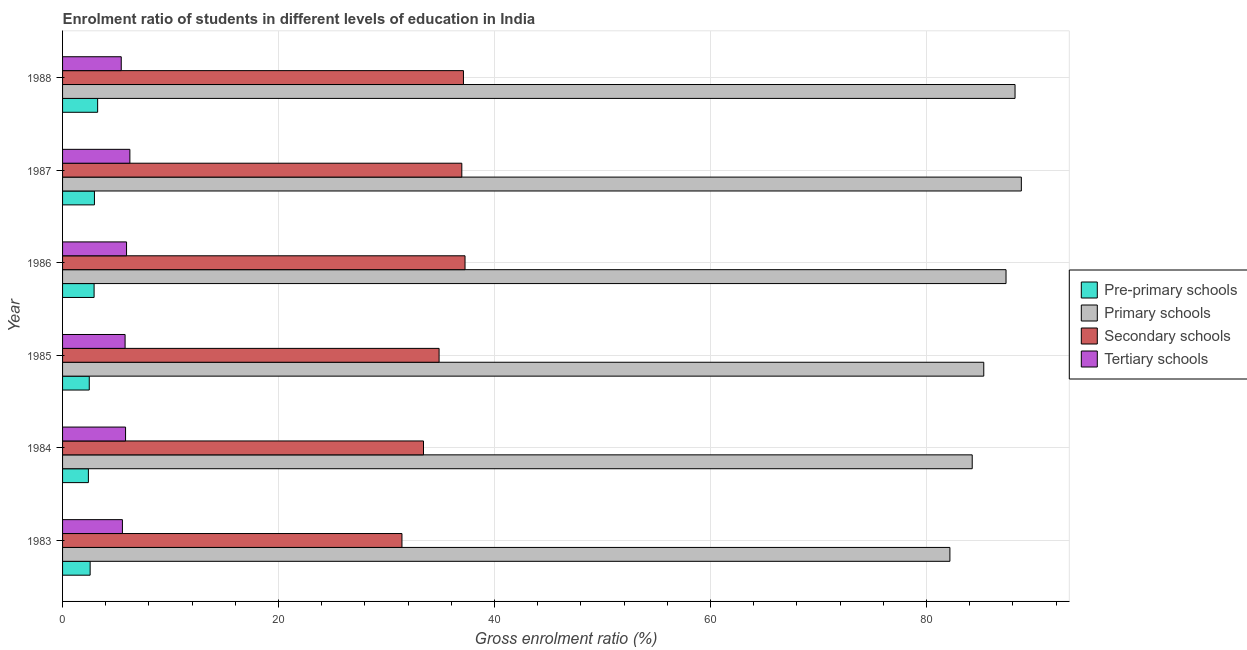How many groups of bars are there?
Keep it short and to the point. 6. Are the number of bars per tick equal to the number of legend labels?
Provide a succinct answer. Yes. What is the gross enrolment ratio in pre-primary schools in 1985?
Your response must be concise. 2.47. Across all years, what is the maximum gross enrolment ratio in tertiary schools?
Your answer should be very brief. 6.23. Across all years, what is the minimum gross enrolment ratio in pre-primary schools?
Ensure brevity in your answer.  2.39. In which year was the gross enrolment ratio in pre-primary schools maximum?
Your answer should be compact. 1988. What is the total gross enrolment ratio in tertiary schools in the graph?
Your answer should be very brief. 34.76. What is the difference between the gross enrolment ratio in primary schools in 1984 and that in 1987?
Your answer should be compact. -4.55. What is the difference between the gross enrolment ratio in pre-primary schools in 1988 and the gross enrolment ratio in secondary schools in 1983?
Offer a terse response. -28.18. What is the average gross enrolment ratio in primary schools per year?
Provide a short and direct response. 86.01. In the year 1987, what is the difference between the gross enrolment ratio in secondary schools and gross enrolment ratio in pre-primary schools?
Your answer should be very brief. 34.02. What is the ratio of the gross enrolment ratio in pre-primary schools in 1983 to that in 1988?
Keep it short and to the point. 0.79. Is the gross enrolment ratio in primary schools in 1984 less than that in 1988?
Make the answer very short. Yes. Is the difference between the gross enrolment ratio in pre-primary schools in 1984 and 1986 greater than the difference between the gross enrolment ratio in tertiary schools in 1984 and 1986?
Ensure brevity in your answer.  No. What is the difference between the highest and the second highest gross enrolment ratio in primary schools?
Your answer should be very brief. 0.58. What is the difference between the highest and the lowest gross enrolment ratio in tertiary schools?
Your answer should be compact. 0.8. Is the sum of the gross enrolment ratio in secondary schools in 1985 and 1988 greater than the maximum gross enrolment ratio in primary schools across all years?
Offer a terse response. No. What does the 2nd bar from the top in 1985 represents?
Your answer should be compact. Secondary schools. What does the 3rd bar from the bottom in 1984 represents?
Offer a terse response. Secondary schools. How many years are there in the graph?
Keep it short and to the point. 6. Are the values on the major ticks of X-axis written in scientific E-notation?
Provide a short and direct response. No. Does the graph contain any zero values?
Provide a succinct answer. No. How are the legend labels stacked?
Give a very brief answer. Vertical. What is the title of the graph?
Ensure brevity in your answer.  Enrolment ratio of students in different levels of education in India. Does "PFC gas" appear as one of the legend labels in the graph?
Make the answer very short. No. What is the label or title of the X-axis?
Offer a very short reply. Gross enrolment ratio (%). What is the Gross enrolment ratio (%) in Pre-primary schools in 1983?
Give a very brief answer. 2.55. What is the Gross enrolment ratio (%) of Primary schools in 1983?
Your response must be concise. 82.17. What is the Gross enrolment ratio (%) of Secondary schools in 1983?
Your answer should be very brief. 31.43. What is the Gross enrolment ratio (%) in Tertiary schools in 1983?
Your answer should be very brief. 5.54. What is the Gross enrolment ratio (%) of Pre-primary schools in 1984?
Ensure brevity in your answer.  2.39. What is the Gross enrolment ratio (%) of Primary schools in 1984?
Your response must be concise. 84.24. What is the Gross enrolment ratio (%) in Secondary schools in 1984?
Keep it short and to the point. 33.42. What is the Gross enrolment ratio (%) of Tertiary schools in 1984?
Offer a very short reply. 5.83. What is the Gross enrolment ratio (%) of Pre-primary schools in 1985?
Your answer should be compact. 2.47. What is the Gross enrolment ratio (%) of Primary schools in 1985?
Keep it short and to the point. 85.3. What is the Gross enrolment ratio (%) of Secondary schools in 1985?
Make the answer very short. 34.87. What is the Gross enrolment ratio (%) of Tertiary schools in 1985?
Keep it short and to the point. 5.79. What is the Gross enrolment ratio (%) in Pre-primary schools in 1986?
Your response must be concise. 2.92. What is the Gross enrolment ratio (%) of Primary schools in 1986?
Give a very brief answer. 87.37. What is the Gross enrolment ratio (%) in Secondary schools in 1986?
Your response must be concise. 37.27. What is the Gross enrolment ratio (%) in Tertiary schools in 1986?
Your answer should be very brief. 5.92. What is the Gross enrolment ratio (%) of Pre-primary schools in 1987?
Provide a short and direct response. 2.95. What is the Gross enrolment ratio (%) of Primary schools in 1987?
Keep it short and to the point. 88.79. What is the Gross enrolment ratio (%) in Secondary schools in 1987?
Provide a succinct answer. 36.97. What is the Gross enrolment ratio (%) in Tertiary schools in 1987?
Keep it short and to the point. 6.23. What is the Gross enrolment ratio (%) of Pre-primary schools in 1988?
Provide a succinct answer. 3.25. What is the Gross enrolment ratio (%) of Primary schools in 1988?
Your answer should be compact. 88.2. What is the Gross enrolment ratio (%) of Secondary schools in 1988?
Your response must be concise. 37.12. What is the Gross enrolment ratio (%) in Tertiary schools in 1988?
Offer a very short reply. 5.43. Across all years, what is the maximum Gross enrolment ratio (%) of Pre-primary schools?
Your response must be concise. 3.25. Across all years, what is the maximum Gross enrolment ratio (%) of Primary schools?
Your answer should be very brief. 88.79. Across all years, what is the maximum Gross enrolment ratio (%) of Secondary schools?
Your response must be concise. 37.27. Across all years, what is the maximum Gross enrolment ratio (%) in Tertiary schools?
Your answer should be very brief. 6.23. Across all years, what is the minimum Gross enrolment ratio (%) of Pre-primary schools?
Keep it short and to the point. 2.39. Across all years, what is the minimum Gross enrolment ratio (%) of Primary schools?
Your answer should be compact. 82.17. Across all years, what is the minimum Gross enrolment ratio (%) in Secondary schools?
Provide a succinct answer. 31.43. Across all years, what is the minimum Gross enrolment ratio (%) of Tertiary schools?
Ensure brevity in your answer.  5.43. What is the total Gross enrolment ratio (%) in Pre-primary schools in the graph?
Give a very brief answer. 16.54. What is the total Gross enrolment ratio (%) of Primary schools in the graph?
Provide a succinct answer. 516.06. What is the total Gross enrolment ratio (%) in Secondary schools in the graph?
Your answer should be compact. 211.08. What is the total Gross enrolment ratio (%) of Tertiary schools in the graph?
Give a very brief answer. 34.76. What is the difference between the Gross enrolment ratio (%) of Pre-primary schools in 1983 and that in 1984?
Provide a short and direct response. 0.16. What is the difference between the Gross enrolment ratio (%) in Primary schools in 1983 and that in 1984?
Provide a succinct answer. -2.07. What is the difference between the Gross enrolment ratio (%) of Secondary schools in 1983 and that in 1984?
Provide a short and direct response. -1.99. What is the difference between the Gross enrolment ratio (%) of Tertiary schools in 1983 and that in 1984?
Offer a terse response. -0.29. What is the difference between the Gross enrolment ratio (%) in Pre-primary schools in 1983 and that in 1985?
Your response must be concise. 0.08. What is the difference between the Gross enrolment ratio (%) of Primary schools in 1983 and that in 1985?
Provide a short and direct response. -3.13. What is the difference between the Gross enrolment ratio (%) in Secondary schools in 1983 and that in 1985?
Provide a succinct answer. -3.44. What is the difference between the Gross enrolment ratio (%) of Tertiary schools in 1983 and that in 1985?
Keep it short and to the point. -0.25. What is the difference between the Gross enrolment ratio (%) of Pre-primary schools in 1983 and that in 1986?
Make the answer very short. -0.37. What is the difference between the Gross enrolment ratio (%) in Primary schools in 1983 and that in 1986?
Your answer should be compact. -5.2. What is the difference between the Gross enrolment ratio (%) in Secondary schools in 1983 and that in 1986?
Your answer should be very brief. -5.84. What is the difference between the Gross enrolment ratio (%) of Tertiary schools in 1983 and that in 1986?
Give a very brief answer. -0.38. What is the difference between the Gross enrolment ratio (%) of Pre-primary schools in 1983 and that in 1987?
Provide a succinct answer. -0.4. What is the difference between the Gross enrolment ratio (%) in Primary schools in 1983 and that in 1987?
Offer a very short reply. -6.62. What is the difference between the Gross enrolment ratio (%) of Secondary schools in 1983 and that in 1987?
Offer a terse response. -5.54. What is the difference between the Gross enrolment ratio (%) of Tertiary schools in 1983 and that in 1987?
Keep it short and to the point. -0.69. What is the difference between the Gross enrolment ratio (%) in Pre-primary schools in 1983 and that in 1988?
Make the answer very short. -0.69. What is the difference between the Gross enrolment ratio (%) in Primary schools in 1983 and that in 1988?
Offer a terse response. -6.03. What is the difference between the Gross enrolment ratio (%) of Secondary schools in 1983 and that in 1988?
Your answer should be very brief. -5.69. What is the difference between the Gross enrolment ratio (%) in Tertiary schools in 1983 and that in 1988?
Provide a succinct answer. 0.11. What is the difference between the Gross enrolment ratio (%) of Pre-primary schools in 1984 and that in 1985?
Your response must be concise. -0.08. What is the difference between the Gross enrolment ratio (%) of Primary schools in 1984 and that in 1985?
Your answer should be compact. -1.07. What is the difference between the Gross enrolment ratio (%) in Secondary schools in 1984 and that in 1985?
Provide a succinct answer. -1.44. What is the difference between the Gross enrolment ratio (%) in Tertiary schools in 1984 and that in 1985?
Offer a very short reply. 0.04. What is the difference between the Gross enrolment ratio (%) of Pre-primary schools in 1984 and that in 1986?
Provide a succinct answer. -0.53. What is the difference between the Gross enrolment ratio (%) of Primary schools in 1984 and that in 1986?
Your answer should be very brief. -3.13. What is the difference between the Gross enrolment ratio (%) in Secondary schools in 1984 and that in 1986?
Your response must be concise. -3.85. What is the difference between the Gross enrolment ratio (%) of Tertiary schools in 1984 and that in 1986?
Your answer should be very brief. -0.09. What is the difference between the Gross enrolment ratio (%) in Pre-primary schools in 1984 and that in 1987?
Your answer should be compact. -0.56. What is the difference between the Gross enrolment ratio (%) of Primary schools in 1984 and that in 1987?
Keep it short and to the point. -4.55. What is the difference between the Gross enrolment ratio (%) of Secondary schools in 1984 and that in 1987?
Offer a very short reply. -3.55. What is the difference between the Gross enrolment ratio (%) in Tertiary schools in 1984 and that in 1987?
Make the answer very short. -0.4. What is the difference between the Gross enrolment ratio (%) in Pre-primary schools in 1984 and that in 1988?
Make the answer very short. -0.86. What is the difference between the Gross enrolment ratio (%) in Primary schools in 1984 and that in 1988?
Offer a terse response. -3.97. What is the difference between the Gross enrolment ratio (%) in Secondary schools in 1984 and that in 1988?
Your response must be concise. -3.7. What is the difference between the Gross enrolment ratio (%) in Tertiary schools in 1984 and that in 1988?
Provide a succinct answer. 0.4. What is the difference between the Gross enrolment ratio (%) of Pre-primary schools in 1985 and that in 1986?
Provide a short and direct response. -0.45. What is the difference between the Gross enrolment ratio (%) of Primary schools in 1985 and that in 1986?
Your answer should be very brief. -2.06. What is the difference between the Gross enrolment ratio (%) of Secondary schools in 1985 and that in 1986?
Provide a short and direct response. -2.4. What is the difference between the Gross enrolment ratio (%) in Tertiary schools in 1985 and that in 1986?
Offer a terse response. -0.13. What is the difference between the Gross enrolment ratio (%) in Pre-primary schools in 1985 and that in 1987?
Offer a very short reply. -0.48. What is the difference between the Gross enrolment ratio (%) in Primary schools in 1985 and that in 1987?
Keep it short and to the point. -3.48. What is the difference between the Gross enrolment ratio (%) in Secondary schools in 1985 and that in 1987?
Offer a very short reply. -2.1. What is the difference between the Gross enrolment ratio (%) in Tertiary schools in 1985 and that in 1987?
Your answer should be very brief. -0.44. What is the difference between the Gross enrolment ratio (%) of Pre-primary schools in 1985 and that in 1988?
Make the answer very short. -0.78. What is the difference between the Gross enrolment ratio (%) of Primary schools in 1985 and that in 1988?
Offer a very short reply. -2.9. What is the difference between the Gross enrolment ratio (%) in Secondary schools in 1985 and that in 1988?
Provide a succinct answer. -2.26. What is the difference between the Gross enrolment ratio (%) of Tertiary schools in 1985 and that in 1988?
Offer a terse response. 0.36. What is the difference between the Gross enrolment ratio (%) of Pre-primary schools in 1986 and that in 1987?
Your response must be concise. -0.03. What is the difference between the Gross enrolment ratio (%) of Primary schools in 1986 and that in 1987?
Your answer should be very brief. -1.42. What is the difference between the Gross enrolment ratio (%) in Secondary schools in 1986 and that in 1987?
Provide a short and direct response. 0.3. What is the difference between the Gross enrolment ratio (%) of Tertiary schools in 1986 and that in 1987?
Keep it short and to the point. -0.31. What is the difference between the Gross enrolment ratio (%) of Pre-primary schools in 1986 and that in 1988?
Keep it short and to the point. -0.33. What is the difference between the Gross enrolment ratio (%) of Primary schools in 1986 and that in 1988?
Keep it short and to the point. -0.84. What is the difference between the Gross enrolment ratio (%) of Secondary schools in 1986 and that in 1988?
Your response must be concise. 0.15. What is the difference between the Gross enrolment ratio (%) of Tertiary schools in 1986 and that in 1988?
Your response must be concise. 0.49. What is the difference between the Gross enrolment ratio (%) of Pre-primary schools in 1987 and that in 1988?
Your answer should be very brief. -0.3. What is the difference between the Gross enrolment ratio (%) in Primary schools in 1987 and that in 1988?
Your answer should be compact. 0.58. What is the difference between the Gross enrolment ratio (%) in Secondary schools in 1987 and that in 1988?
Make the answer very short. -0.15. What is the difference between the Gross enrolment ratio (%) of Tertiary schools in 1987 and that in 1988?
Offer a very short reply. 0.8. What is the difference between the Gross enrolment ratio (%) of Pre-primary schools in 1983 and the Gross enrolment ratio (%) of Primary schools in 1984?
Offer a very short reply. -81.68. What is the difference between the Gross enrolment ratio (%) in Pre-primary schools in 1983 and the Gross enrolment ratio (%) in Secondary schools in 1984?
Provide a succinct answer. -30.87. What is the difference between the Gross enrolment ratio (%) of Pre-primary schools in 1983 and the Gross enrolment ratio (%) of Tertiary schools in 1984?
Ensure brevity in your answer.  -3.28. What is the difference between the Gross enrolment ratio (%) of Primary schools in 1983 and the Gross enrolment ratio (%) of Secondary schools in 1984?
Provide a short and direct response. 48.75. What is the difference between the Gross enrolment ratio (%) of Primary schools in 1983 and the Gross enrolment ratio (%) of Tertiary schools in 1984?
Provide a short and direct response. 76.34. What is the difference between the Gross enrolment ratio (%) in Secondary schools in 1983 and the Gross enrolment ratio (%) in Tertiary schools in 1984?
Keep it short and to the point. 25.59. What is the difference between the Gross enrolment ratio (%) in Pre-primary schools in 1983 and the Gross enrolment ratio (%) in Primary schools in 1985?
Keep it short and to the point. -82.75. What is the difference between the Gross enrolment ratio (%) of Pre-primary schools in 1983 and the Gross enrolment ratio (%) of Secondary schools in 1985?
Your answer should be compact. -32.31. What is the difference between the Gross enrolment ratio (%) of Pre-primary schools in 1983 and the Gross enrolment ratio (%) of Tertiary schools in 1985?
Your answer should be compact. -3.24. What is the difference between the Gross enrolment ratio (%) in Primary schools in 1983 and the Gross enrolment ratio (%) in Secondary schools in 1985?
Provide a succinct answer. 47.3. What is the difference between the Gross enrolment ratio (%) in Primary schools in 1983 and the Gross enrolment ratio (%) in Tertiary schools in 1985?
Offer a very short reply. 76.38. What is the difference between the Gross enrolment ratio (%) of Secondary schools in 1983 and the Gross enrolment ratio (%) of Tertiary schools in 1985?
Give a very brief answer. 25.64. What is the difference between the Gross enrolment ratio (%) of Pre-primary schools in 1983 and the Gross enrolment ratio (%) of Primary schools in 1986?
Your answer should be very brief. -84.81. What is the difference between the Gross enrolment ratio (%) of Pre-primary schools in 1983 and the Gross enrolment ratio (%) of Secondary schools in 1986?
Ensure brevity in your answer.  -34.72. What is the difference between the Gross enrolment ratio (%) of Pre-primary schools in 1983 and the Gross enrolment ratio (%) of Tertiary schools in 1986?
Your answer should be compact. -3.37. What is the difference between the Gross enrolment ratio (%) in Primary schools in 1983 and the Gross enrolment ratio (%) in Secondary schools in 1986?
Give a very brief answer. 44.9. What is the difference between the Gross enrolment ratio (%) in Primary schools in 1983 and the Gross enrolment ratio (%) in Tertiary schools in 1986?
Make the answer very short. 76.25. What is the difference between the Gross enrolment ratio (%) of Secondary schools in 1983 and the Gross enrolment ratio (%) of Tertiary schools in 1986?
Your response must be concise. 25.5. What is the difference between the Gross enrolment ratio (%) in Pre-primary schools in 1983 and the Gross enrolment ratio (%) in Primary schools in 1987?
Your answer should be compact. -86.23. What is the difference between the Gross enrolment ratio (%) in Pre-primary schools in 1983 and the Gross enrolment ratio (%) in Secondary schools in 1987?
Provide a succinct answer. -34.42. What is the difference between the Gross enrolment ratio (%) of Pre-primary schools in 1983 and the Gross enrolment ratio (%) of Tertiary schools in 1987?
Your answer should be compact. -3.68. What is the difference between the Gross enrolment ratio (%) of Primary schools in 1983 and the Gross enrolment ratio (%) of Secondary schools in 1987?
Offer a terse response. 45.2. What is the difference between the Gross enrolment ratio (%) of Primary schools in 1983 and the Gross enrolment ratio (%) of Tertiary schools in 1987?
Your answer should be very brief. 75.94. What is the difference between the Gross enrolment ratio (%) of Secondary schools in 1983 and the Gross enrolment ratio (%) of Tertiary schools in 1987?
Keep it short and to the point. 25.2. What is the difference between the Gross enrolment ratio (%) of Pre-primary schools in 1983 and the Gross enrolment ratio (%) of Primary schools in 1988?
Offer a terse response. -85.65. What is the difference between the Gross enrolment ratio (%) of Pre-primary schools in 1983 and the Gross enrolment ratio (%) of Secondary schools in 1988?
Your response must be concise. -34.57. What is the difference between the Gross enrolment ratio (%) of Pre-primary schools in 1983 and the Gross enrolment ratio (%) of Tertiary schools in 1988?
Offer a terse response. -2.88. What is the difference between the Gross enrolment ratio (%) in Primary schools in 1983 and the Gross enrolment ratio (%) in Secondary schools in 1988?
Make the answer very short. 45.05. What is the difference between the Gross enrolment ratio (%) of Primary schools in 1983 and the Gross enrolment ratio (%) of Tertiary schools in 1988?
Make the answer very short. 76.74. What is the difference between the Gross enrolment ratio (%) of Secondary schools in 1983 and the Gross enrolment ratio (%) of Tertiary schools in 1988?
Your answer should be very brief. 25.99. What is the difference between the Gross enrolment ratio (%) of Pre-primary schools in 1984 and the Gross enrolment ratio (%) of Primary schools in 1985?
Provide a succinct answer. -82.91. What is the difference between the Gross enrolment ratio (%) of Pre-primary schools in 1984 and the Gross enrolment ratio (%) of Secondary schools in 1985?
Give a very brief answer. -32.47. What is the difference between the Gross enrolment ratio (%) in Pre-primary schools in 1984 and the Gross enrolment ratio (%) in Tertiary schools in 1985?
Your response must be concise. -3.4. What is the difference between the Gross enrolment ratio (%) in Primary schools in 1984 and the Gross enrolment ratio (%) in Secondary schools in 1985?
Your answer should be compact. 49.37. What is the difference between the Gross enrolment ratio (%) in Primary schools in 1984 and the Gross enrolment ratio (%) in Tertiary schools in 1985?
Your answer should be compact. 78.45. What is the difference between the Gross enrolment ratio (%) of Secondary schools in 1984 and the Gross enrolment ratio (%) of Tertiary schools in 1985?
Your answer should be very brief. 27.63. What is the difference between the Gross enrolment ratio (%) in Pre-primary schools in 1984 and the Gross enrolment ratio (%) in Primary schools in 1986?
Make the answer very short. -84.98. What is the difference between the Gross enrolment ratio (%) in Pre-primary schools in 1984 and the Gross enrolment ratio (%) in Secondary schools in 1986?
Make the answer very short. -34.88. What is the difference between the Gross enrolment ratio (%) in Pre-primary schools in 1984 and the Gross enrolment ratio (%) in Tertiary schools in 1986?
Your answer should be very brief. -3.53. What is the difference between the Gross enrolment ratio (%) in Primary schools in 1984 and the Gross enrolment ratio (%) in Secondary schools in 1986?
Your answer should be compact. 46.97. What is the difference between the Gross enrolment ratio (%) of Primary schools in 1984 and the Gross enrolment ratio (%) of Tertiary schools in 1986?
Keep it short and to the point. 78.31. What is the difference between the Gross enrolment ratio (%) in Secondary schools in 1984 and the Gross enrolment ratio (%) in Tertiary schools in 1986?
Offer a very short reply. 27.5. What is the difference between the Gross enrolment ratio (%) of Pre-primary schools in 1984 and the Gross enrolment ratio (%) of Primary schools in 1987?
Offer a very short reply. -86.39. What is the difference between the Gross enrolment ratio (%) in Pre-primary schools in 1984 and the Gross enrolment ratio (%) in Secondary schools in 1987?
Provide a succinct answer. -34.58. What is the difference between the Gross enrolment ratio (%) in Pre-primary schools in 1984 and the Gross enrolment ratio (%) in Tertiary schools in 1987?
Give a very brief answer. -3.84. What is the difference between the Gross enrolment ratio (%) in Primary schools in 1984 and the Gross enrolment ratio (%) in Secondary schools in 1987?
Ensure brevity in your answer.  47.26. What is the difference between the Gross enrolment ratio (%) of Primary schools in 1984 and the Gross enrolment ratio (%) of Tertiary schools in 1987?
Your answer should be compact. 78. What is the difference between the Gross enrolment ratio (%) of Secondary schools in 1984 and the Gross enrolment ratio (%) of Tertiary schools in 1987?
Make the answer very short. 27.19. What is the difference between the Gross enrolment ratio (%) in Pre-primary schools in 1984 and the Gross enrolment ratio (%) in Primary schools in 1988?
Your answer should be very brief. -85.81. What is the difference between the Gross enrolment ratio (%) of Pre-primary schools in 1984 and the Gross enrolment ratio (%) of Secondary schools in 1988?
Keep it short and to the point. -34.73. What is the difference between the Gross enrolment ratio (%) in Pre-primary schools in 1984 and the Gross enrolment ratio (%) in Tertiary schools in 1988?
Make the answer very short. -3.04. What is the difference between the Gross enrolment ratio (%) of Primary schools in 1984 and the Gross enrolment ratio (%) of Secondary schools in 1988?
Ensure brevity in your answer.  47.11. What is the difference between the Gross enrolment ratio (%) of Primary schools in 1984 and the Gross enrolment ratio (%) of Tertiary schools in 1988?
Your answer should be very brief. 78.8. What is the difference between the Gross enrolment ratio (%) of Secondary schools in 1984 and the Gross enrolment ratio (%) of Tertiary schools in 1988?
Provide a short and direct response. 27.99. What is the difference between the Gross enrolment ratio (%) of Pre-primary schools in 1985 and the Gross enrolment ratio (%) of Primary schools in 1986?
Offer a terse response. -84.89. What is the difference between the Gross enrolment ratio (%) in Pre-primary schools in 1985 and the Gross enrolment ratio (%) in Secondary schools in 1986?
Offer a terse response. -34.8. What is the difference between the Gross enrolment ratio (%) in Pre-primary schools in 1985 and the Gross enrolment ratio (%) in Tertiary schools in 1986?
Your answer should be compact. -3.45. What is the difference between the Gross enrolment ratio (%) of Primary schools in 1985 and the Gross enrolment ratio (%) of Secondary schools in 1986?
Provide a succinct answer. 48.03. What is the difference between the Gross enrolment ratio (%) of Primary schools in 1985 and the Gross enrolment ratio (%) of Tertiary schools in 1986?
Offer a terse response. 79.38. What is the difference between the Gross enrolment ratio (%) of Secondary schools in 1985 and the Gross enrolment ratio (%) of Tertiary schools in 1986?
Your response must be concise. 28.94. What is the difference between the Gross enrolment ratio (%) in Pre-primary schools in 1985 and the Gross enrolment ratio (%) in Primary schools in 1987?
Offer a very short reply. -86.31. What is the difference between the Gross enrolment ratio (%) in Pre-primary schools in 1985 and the Gross enrolment ratio (%) in Secondary schools in 1987?
Your answer should be very brief. -34.5. What is the difference between the Gross enrolment ratio (%) in Pre-primary schools in 1985 and the Gross enrolment ratio (%) in Tertiary schools in 1987?
Make the answer very short. -3.76. What is the difference between the Gross enrolment ratio (%) in Primary schools in 1985 and the Gross enrolment ratio (%) in Secondary schools in 1987?
Offer a very short reply. 48.33. What is the difference between the Gross enrolment ratio (%) of Primary schools in 1985 and the Gross enrolment ratio (%) of Tertiary schools in 1987?
Your answer should be compact. 79.07. What is the difference between the Gross enrolment ratio (%) of Secondary schools in 1985 and the Gross enrolment ratio (%) of Tertiary schools in 1987?
Your answer should be very brief. 28.63. What is the difference between the Gross enrolment ratio (%) in Pre-primary schools in 1985 and the Gross enrolment ratio (%) in Primary schools in 1988?
Your answer should be compact. -85.73. What is the difference between the Gross enrolment ratio (%) of Pre-primary schools in 1985 and the Gross enrolment ratio (%) of Secondary schools in 1988?
Provide a succinct answer. -34.65. What is the difference between the Gross enrolment ratio (%) in Pre-primary schools in 1985 and the Gross enrolment ratio (%) in Tertiary schools in 1988?
Give a very brief answer. -2.96. What is the difference between the Gross enrolment ratio (%) of Primary schools in 1985 and the Gross enrolment ratio (%) of Secondary schools in 1988?
Provide a short and direct response. 48.18. What is the difference between the Gross enrolment ratio (%) in Primary schools in 1985 and the Gross enrolment ratio (%) in Tertiary schools in 1988?
Your response must be concise. 79.87. What is the difference between the Gross enrolment ratio (%) of Secondary schools in 1985 and the Gross enrolment ratio (%) of Tertiary schools in 1988?
Your answer should be very brief. 29.43. What is the difference between the Gross enrolment ratio (%) of Pre-primary schools in 1986 and the Gross enrolment ratio (%) of Primary schools in 1987?
Make the answer very short. -85.87. What is the difference between the Gross enrolment ratio (%) of Pre-primary schools in 1986 and the Gross enrolment ratio (%) of Secondary schools in 1987?
Offer a very short reply. -34.05. What is the difference between the Gross enrolment ratio (%) in Pre-primary schools in 1986 and the Gross enrolment ratio (%) in Tertiary schools in 1987?
Offer a terse response. -3.31. What is the difference between the Gross enrolment ratio (%) in Primary schools in 1986 and the Gross enrolment ratio (%) in Secondary schools in 1987?
Your answer should be compact. 50.4. What is the difference between the Gross enrolment ratio (%) in Primary schools in 1986 and the Gross enrolment ratio (%) in Tertiary schools in 1987?
Make the answer very short. 81.13. What is the difference between the Gross enrolment ratio (%) of Secondary schools in 1986 and the Gross enrolment ratio (%) of Tertiary schools in 1987?
Offer a very short reply. 31.04. What is the difference between the Gross enrolment ratio (%) of Pre-primary schools in 1986 and the Gross enrolment ratio (%) of Primary schools in 1988?
Make the answer very short. -85.28. What is the difference between the Gross enrolment ratio (%) in Pre-primary schools in 1986 and the Gross enrolment ratio (%) in Secondary schools in 1988?
Your answer should be compact. -34.2. What is the difference between the Gross enrolment ratio (%) in Pre-primary schools in 1986 and the Gross enrolment ratio (%) in Tertiary schools in 1988?
Provide a succinct answer. -2.51. What is the difference between the Gross enrolment ratio (%) of Primary schools in 1986 and the Gross enrolment ratio (%) of Secondary schools in 1988?
Your answer should be compact. 50.24. What is the difference between the Gross enrolment ratio (%) of Primary schools in 1986 and the Gross enrolment ratio (%) of Tertiary schools in 1988?
Your answer should be compact. 81.93. What is the difference between the Gross enrolment ratio (%) of Secondary schools in 1986 and the Gross enrolment ratio (%) of Tertiary schools in 1988?
Provide a short and direct response. 31.84. What is the difference between the Gross enrolment ratio (%) in Pre-primary schools in 1987 and the Gross enrolment ratio (%) in Primary schools in 1988?
Keep it short and to the point. -85.25. What is the difference between the Gross enrolment ratio (%) in Pre-primary schools in 1987 and the Gross enrolment ratio (%) in Secondary schools in 1988?
Make the answer very short. -34.17. What is the difference between the Gross enrolment ratio (%) of Pre-primary schools in 1987 and the Gross enrolment ratio (%) of Tertiary schools in 1988?
Offer a very short reply. -2.48. What is the difference between the Gross enrolment ratio (%) in Primary schools in 1987 and the Gross enrolment ratio (%) in Secondary schools in 1988?
Give a very brief answer. 51.66. What is the difference between the Gross enrolment ratio (%) in Primary schools in 1987 and the Gross enrolment ratio (%) in Tertiary schools in 1988?
Your answer should be compact. 83.35. What is the difference between the Gross enrolment ratio (%) in Secondary schools in 1987 and the Gross enrolment ratio (%) in Tertiary schools in 1988?
Your answer should be compact. 31.54. What is the average Gross enrolment ratio (%) of Pre-primary schools per year?
Keep it short and to the point. 2.76. What is the average Gross enrolment ratio (%) in Primary schools per year?
Make the answer very short. 86.01. What is the average Gross enrolment ratio (%) of Secondary schools per year?
Offer a terse response. 35.18. What is the average Gross enrolment ratio (%) in Tertiary schools per year?
Ensure brevity in your answer.  5.79. In the year 1983, what is the difference between the Gross enrolment ratio (%) in Pre-primary schools and Gross enrolment ratio (%) in Primary schools?
Your answer should be compact. -79.62. In the year 1983, what is the difference between the Gross enrolment ratio (%) in Pre-primary schools and Gross enrolment ratio (%) in Secondary schools?
Your answer should be very brief. -28.87. In the year 1983, what is the difference between the Gross enrolment ratio (%) in Pre-primary schools and Gross enrolment ratio (%) in Tertiary schools?
Give a very brief answer. -2.99. In the year 1983, what is the difference between the Gross enrolment ratio (%) in Primary schools and Gross enrolment ratio (%) in Secondary schools?
Ensure brevity in your answer.  50.74. In the year 1983, what is the difference between the Gross enrolment ratio (%) of Primary schools and Gross enrolment ratio (%) of Tertiary schools?
Ensure brevity in your answer.  76.63. In the year 1983, what is the difference between the Gross enrolment ratio (%) in Secondary schools and Gross enrolment ratio (%) in Tertiary schools?
Offer a terse response. 25.89. In the year 1984, what is the difference between the Gross enrolment ratio (%) of Pre-primary schools and Gross enrolment ratio (%) of Primary schools?
Give a very brief answer. -81.84. In the year 1984, what is the difference between the Gross enrolment ratio (%) in Pre-primary schools and Gross enrolment ratio (%) in Secondary schools?
Keep it short and to the point. -31.03. In the year 1984, what is the difference between the Gross enrolment ratio (%) of Pre-primary schools and Gross enrolment ratio (%) of Tertiary schools?
Your answer should be compact. -3.44. In the year 1984, what is the difference between the Gross enrolment ratio (%) in Primary schools and Gross enrolment ratio (%) in Secondary schools?
Provide a short and direct response. 50.81. In the year 1984, what is the difference between the Gross enrolment ratio (%) of Primary schools and Gross enrolment ratio (%) of Tertiary schools?
Ensure brevity in your answer.  78.4. In the year 1984, what is the difference between the Gross enrolment ratio (%) in Secondary schools and Gross enrolment ratio (%) in Tertiary schools?
Offer a terse response. 27.59. In the year 1985, what is the difference between the Gross enrolment ratio (%) in Pre-primary schools and Gross enrolment ratio (%) in Primary schools?
Keep it short and to the point. -82.83. In the year 1985, what is the difference between the Gross enrolment ratio (%) of Pre-primary schools and Gross enrolment ratio (%) of Secondary schools?
Make the answer very short. -32.39. In the year 1985, what is the difference between the Gross enrolment ratio (%) of Pre-primary schools and Gross enrolment ratio (%) of Tertiary schools?
Make the answer very short. -3.32. In the year 1985, what is the difference between the Gross enrolment ratio (%) in Primary schools and Gross enrolment ratio (%) in Secondary schools?
Your response must be concise. 50.44. In the year 1985, what is the difference between the Gross enrolment ratio (%) of Primary schools and Gross enrolment ratio (%) of Tertiary schools?
Your answer should be compact. 79.51. In the year 1985, what is the difference between the Gross enrolment ratio (%) in Secondary schools and Gross enrolment ratio (%) in Tertiary schools?
Your answer should be compact. 29.08. In the year 1986, what is the difference between the Gross enrolment ratio (%) of Pre-primary schools and Gross enrolment ratio (%) of Primary schools?
Your answer should be compact. -84.45. In the year 1986, what is the difference between the Gross enrolment ratio (%) in Pre-primary schools and Gross enrolment ratio (%) in Secondary schools?
Offer a terse response. -34.35. In the year 1986, what is the difference between the Gross enrolment ratio (%) of Pre-primary schools and Gross enrolment ratio (%) of Tertiary schools?
Ensure brevity in your answer.  -3. In the year 1986, what is the difference between the Gross enrolment ratio (%) of Primary schools and Gross enrolment ratio (%) of Secondary schools?
Offer a terse response. 50.1. In the year 1986, what is the difference between the Gross enrolment ratio (%) of Primary schools and Gross enrolment ratio (%) of Tertiary schools?
Your answer should be very brief. 81.44. In the year 1986, what is the difference between the Gross enrolment ratio (%) in Secondary schools and Gross enrolment ratio (%) in Tertiary schools?
Keep it short and to the point. 31.35. In the year 1987, what is the difference between the Gross enrolment ratio (%) of Pre-primary schools and Gross enrolment ratio (%) of Primary schools?
Keep it short and to the point. -85.83. In the year 1987, what is the difference between the Gross enrolment ratio (%) of Pre-primary schools and Gross enrolment ratio (%) of Secondary schools?
Ensure brevity in your answer.  -34.02. In the year 1987, what is the difference between the Gross enrolment ratio (%) in Pre-primary schools and Gross enrolment ratio (%) in Tertiary schools?
Your answer should be compact. -3.28. In the year 1987, what is the difference between the Gross enrolment ratio (%) of Primary schools and Gross enrolment ratio (%) of Secondary schools?
Give a very brief answer. 51.81. In the year 1987, what is the difference between the Gross enrolment ratio (%) of Primary schools and Gross enrolment ratio (%) of Tertiary schools?
Your answer should be very brief. 82.55. In the year 1987, what is the difference between the Gross enrolment ratio (%) of Secondary schools and Gross enrolment ratio (%) of Tertiary schools?
Your answer should be very brief. 30.74. In the year 1988, what is the difference between the Gross enrolment ratio (%) of Pre-primary schools and Gross enrolment ratio (%) of Primary schools?
Provide a succinct answer. -84.95. In the year 1988, what is the difference between the Gross enrolment ratio (%) of Pre-primary schools and Gross enrolment ratio (%) of Secondary schools?
Keep it short and to the point. -33.87. In the year 1988, what is the difference between the Gross enrolment ratio (%) of Pre-primary schools and Gross enrolment ratio (%) of Tertiary schools?
Offer a very short reply. -2.19. In the year 1988, what is the difference between the Gross enrolment ratio (%) in Primary schools and Gross enrolment ratio (%) in Secondary schools?
Provide a succinct answer. 51.08. In the year 1988, what is the difference between the Gross enrolment ratio (%) of Primary schools and Gross enrolment ratio (%) of Tertiary schools?
Ensure brevity in your answer.  82.77. In the year 1988, what is the difference between the Gross enrolment ratio (%) of Secondary schools and Gross enrolment ratio (%) of Tertiary schools?
Your answer should be compact. 31.69. What is the ratio of the Gross enrolment ratio (%) of Pre-primary schools in 1983 to that in 1984?
Give a very brief answer. 1.07. What is the ratio of the Gross enrolment ratio (%) of Primary schools in 1983 to that in 1984?
Your response must be concise. 0.98. What is the ratio of the Gross enrolment ratio (%) in Secondary schools in 1983 to that in 1984?
Offer a very short reply. 0.94. What is the ratio of the Gross enrolment ratio (%) of Tertiary schools in 1983 to that in 1984?
Keep it short and to the point. 0.95. What is the ratio of the Gross enrolment ratio (%) in Pre-primary schools in 1983 to that in 1985?
Provide a short and direct response. 1.03. What is the ratio of the Gross enrolment ratio (%) in Primary schools in 1983 to that in 1985?
Provide a succinct answer. 0.96. What is the ratio of the Gross enrolment ratio (%) of Secondary schools in 1983 to that in 1985?
Your answer should be very brief. 0.9. What is the ratio of the Gross enrolment ratio (%) of Tertiary schools in 1983 to that in 1985?
Your answer should be compact. 0.96. What is the ratio of the Gross enrolment ratio (%) of Pre-primary schools in 1983 to that in 1986?
Offer a very short reply. 0.87. What is the ratio of the Gross enrolment ratio (%) in Primary schools in 1983 to that in 1986?
Give a very brief answer. 0.94. What is the ratio of the Gross enrolment ratio (%) in Secondary schools in 1983 to that in 1986?
Provide a short and direct response. 0.84. What is the ratio of the Gross enrolment ratio (%) in Tertiary schools in 1983 to that in 1986?
Offer a very short reply. 0.94. What is the ratio of the Gross enrolment ratio (%) of Pre-primary schools in 1983 to that in 1987?
Ensure brevity in your answer.  0.87. What is the ratio of the Gross enrolment ratio (%) in Primary schools in 1983 to that in 1987?
Keep it short and to the point. 0.93. What is the ratio of the Gross enrolment ratio (%) in Secondary schools in 1983 to that in 1987?
Offer a very short reply. 0.85. What is the ratio of the Gross enrolment ratio (%) of Tertiary schools in 1983 to that in 1987?
Offer a terse response. 0.89. What is the ratio of the Gross enrolment ratio (%) in Pre-primary schools in 1983 to that in 1988?
Provide a short and direct response. 0.79. What is the ratio of the Gross enrolment ratio (%) in Primary schools in 1983 to that in 1988?
Provide a short and direct response. 0.93. What is the ratio of the Gross enrolment ratio (%) of Secondary schools in 1983 to that in 1988?
Ensure brevity in your answer.  0.85. What is the ratio of the Gross enrolment ratio (%) of Tertiary schools in 1983 to that in 1988?
Give a very brief answer. 1.02. What is the ratio of the Gross enrolment ratio (%) of Pre-primary schools in 1984 to that in 1985?
Your answer should be very brief. 0.97. What is the ratio of the Gross enrolment ratio (%) in Primary schools in 1984 to that in 1985?
Provide a succinct answer. 0.99. What is the ratio of the Gross enrolment ratio (%) in Secondary schools in 1984 to that in 1985?
Keep it short and to the point. 0.96. What is the ratio of the Gross enrolment ratio (%) in Tertiary schools in 1984 to that in 1985?
Your answer should be compact. 1.01. What is the ratio of the Gross enrolment ratio (%) of Pre-primary schools in 1984 to that in 1986?
Your response must be concise. 0.82. What is the ratio of the Gross enrolment ratio (%) of Primary schools in 1984 to that in 1986?
Ensure brevity in your answer.  0.96. What is the ratio of the Gross enrolment ratio (%) in Secondary schools in 1984 to that in 1986?
Your answer should be very brief. 0.9. What is the ratio of the Gross enrolment ratio (%) of Pre-primary schools in 1984 to that in 1987?
Your answer should be very brief. 0.81. What is the ratio of the Gross enrolment ratio (%) in Primary schools in 1984 to that in 1987?
Provide a short and direct response. 0.95. What is the ratio of the Gross enrolment ratio (%) in Secondary schools in 1984 to that in 1987?
Give a very brief answer. 0.9. What is the ratio of the Gross enrolment ratio (%) of Tertiary schools in 1984 to that in 1987?
Keep it short and to the point. 0.94. What is the ratio of the Gross enrolment ratio (%) of Pre-primary schools in 1984 to that in 1988?
Keep it short and to the point. 0.74. What is the ratio of the Gross enrolment ratio (%) of Primary schools in 1984 to that in 1988?
Your answer should be very brief. 0.95. What is the ratio of the Gross enrolment ratio (%) in Secondary schools in 1984 to that in 1988?
Your answer should be very brief. 0.9. What is the ratio of the Gross enrolment ratio (%) of Tertiary schools in 1984 to that in 1988?
Your answer should be compact. 1.07. What is the ratio of the Gross enrolment ratio (%) in Pre-primary schools in 1985 to that in 1986?
Provide a short and direct response. 0.85. What is the ratio of the Gross enrolment ratio (%) of Primary schools in 1985 to that in 1986?
Make the answer very short. 0.98. What is the ratio of the Gross enrolment ratio (%) in Secondary schools in 1985 to that in 1986?
Ensure brevity in your answer.  0.94. What is the ratio of the Gross enrolment ratio (%) of Tertiary schools in 1985 to that in 1986?
Your answer should be very brief. 0.98. What is the ratio of the Gross enrolment ratio (%) of Pre-primary schools in 1985 to that in 1987?
Offer a very short reply. 0.84. What is the ratio of the Gross enrolment ratio (%) of Primary schools in 1985 to that in 1987?
Provide a short and direct response. 0.96. What is the ratio of the Gross enrolment ratio (%) in Secondary schools in 1985 to that in 1987?
Ensure brevity in your answer.  0.94. What is the ratio of the Gross enrolment ratio (%) in Tertiary schools in 1985 to that in 1987?
Your answer should be very brief. 0.93. What is the ratio of the Gross enrolment ratio (%) of Pre-primary schools in 1985 to that in 1988?
Provide a succinct answer. 0.76. What is the ratio of the Gross enrolment ratio (%) in Primary schools in 1985 to that in 1988?
Your response must be concise. 0.97. What is the ratio of the Gross enrolment ratio (%) in Secondary schools in 1985 to that in 1988?
Provide a short and direct response. 0.94. What is the ratio of the Gross enrolment ratio (%) in Tertiary schools in 1985 to that in 1988?
Ensure brevity in your answer.  1.07. What is the ratio of the Gross enrolment ratio (%) in Tertiary schools in 1986 to that in 1987?
Offer a very short reply. 0.95. What is the ratio of the Gross enrolment ratio (%) in Pre-primary schools in 1986 to that in 1988?
Your answer should be very brief. 0.9. What is the ratio of the Gross enrolment ratio (%) of Primary schools in 1986 to that in 1988?
Offer a very short reply. 0.99. What is the ratio of the Gross enrolment ratio (%) in Tertiary schools in 1986 to that in 1988?
Give a very brief answer. 1.09. What is the ratio of the Gross enrolment ratio (%) of Pre-primary schools in 1987 to that in 1988?
Give a very brief answer. 0.91. What is the ratio of the Gross enrolment ratio (%) of Primary schools in 1987 to that in 1988?
Ensure brevity in your answer.  1.01. What is the ratio of the Gross enrolment ratio (%) in Tertiary schools in 1987 to that in 1988?
Your response must be concise. 1.15. What is the difference between the highest and the second highest Gross enrolment ratio (%) of Pre-primary schools?
Give a very brief answer. 0.3. What is the difference between the highest and the second highest Gross enrolment ratio (%) in Primary schools?
Offer a terse response. 0.58. What is the difference between the highest and the second highest Gross enrolment ratio (%) of Secondary schools?
Provide a succinct answer. 0.15. What is the difference between the highest and the second highest Gross enrolment ratio (%) of Tertiary schools?
Your answer should be compact. 0.31. What is the difference between the highest and the lowest Gross enrolment ratio (%) in Pre-primary schools?
Provide a succinct answer. 0.86. What is the difference between the highest and the lowest Gross enrolment ratio (%) in Primary schools?
Offer a very short reply. 6.62. What is the difference between the highest and the lowest Gross enrolment ratio (%) of Secondary schools?
Give a very brief answer. 5.84. What is the difference between the highest and the lowest Gross enrolment ratio (%) of Tertiary schools?
Give a very brief answer. 0.8. 